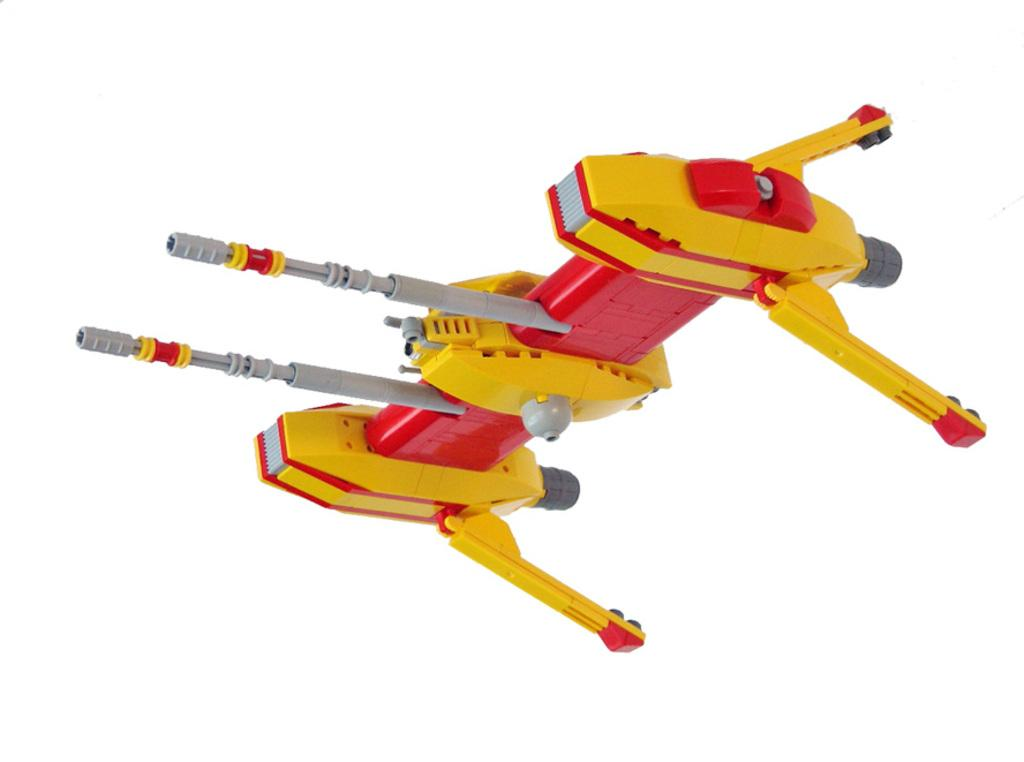What object can be seen in the image? There is a toy in the image. What color is the background of the image? The background of the image is white. How many houses are visible in the image? There are no houses visible in the image; it only features a toy and a white background. What type of dinosaur can be seen interacting with the toy in the image? There are no dinosaurs present in the image; it only features a toy and a white background. 